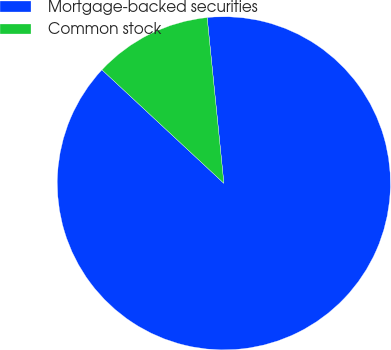<chart> <loc_0><loc_0><loc_500><loc_500><pie_chart><fcel>Mortgage-backed securities<fcel>Common stock<nl><fcel>88.53%<fcel>11.47%<nl></chart> 